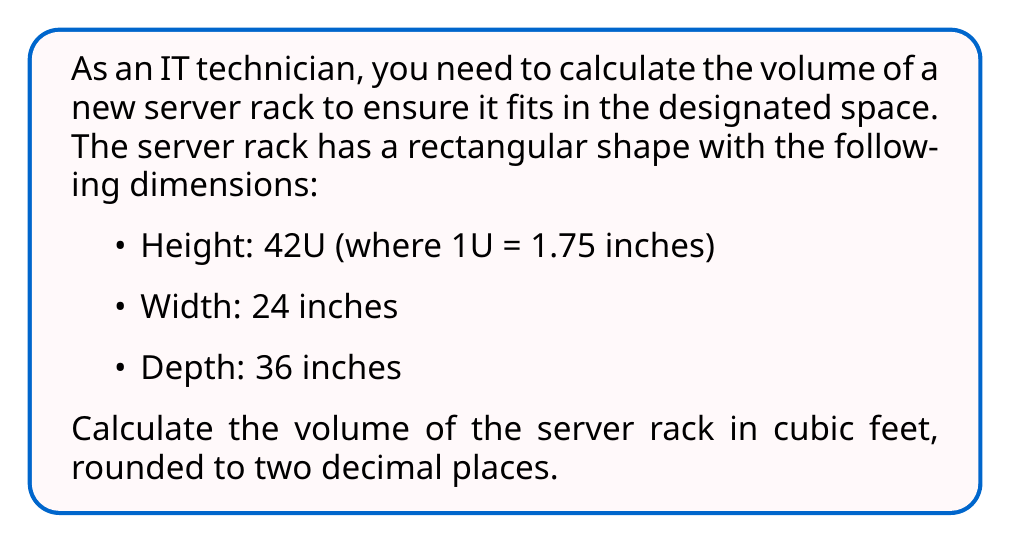Provide a solution to this math problem. To solve this problem, we'll follow these steps:

1. Convert the height from U to inches:
   $$42\text{U} \times 1.75 \text{ inches/U} = 73.5 \text{ inches}$$

2. Calculate the volume in cubic inches:
   $$V = h \times w \times d$$
   $$V = 73.5 \text{ inches} \times 24 \text{ inches} \times 36 \text{ inches}$$
   $$V = 63,504 \text{ cubic inches}$$

3. Convert cubic inches to cubic feet:
   There are 1,728 cubic inches in a cubic foot (12 inches × 12 inches × 12 inches).
   $$V_{\text{ft}^3} = \frac{63,504 \text{ in}^3}{1,728 \text{ in}^3/\text{ft}^3}$$
   $$V_{\text{ft}^3} = 36.75 \text{ ft}^3$$

4. Round to two decimal places:
   $$V_{\text{final}} = 36.75 \text{ ft}^3 \approx 36.75 \text{ ft}^3$$

[asy]
import three;

size(200);
currentprojection=perspective(6,3,2);

draw(box((0,0,0),(24,36,73.5)));

label("24\"", (12,0,0), S);
label("36\"", (24,18,0), E);
label("73.5\"", (24,36,36.75), N);

draw((24,0,0)--(24,0,-5), dashed);
draw((24,36,0)--(24,36,-5), dashed);
draw((24,0,-5)--(24,36,-5), Arrow);
[/asy]
Answer: The volume of the server rack is approximately $36.75 \text{ ft}^3$. 